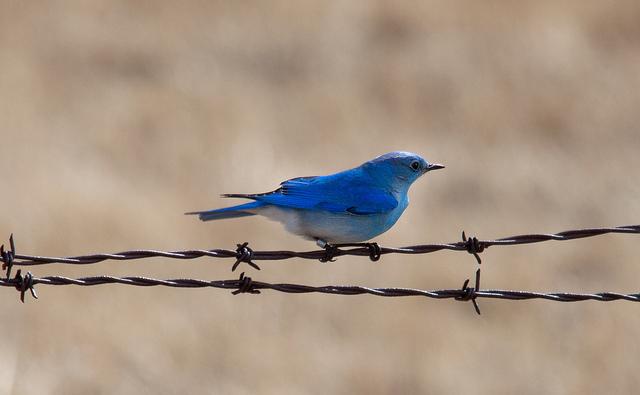What kind of bird is this?
Short answer required. Bluebird. What is the bird sitting on?
Write a very short answer. Wire. Is this bird indoors or outdoors?
Give a very brief answer. Outdoors. 